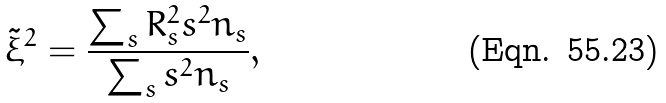<formula> <loc_0><loc_0><loc_500><loc_500>\tilde { \xi } ^ { 2 } = \frac { \sum _ { s } R _ { s } ^ { 2 } s ^ { 2 } n _ { s } } { \sum _ { s } s ^ { 2 } n _ { s } } ,</formula> 